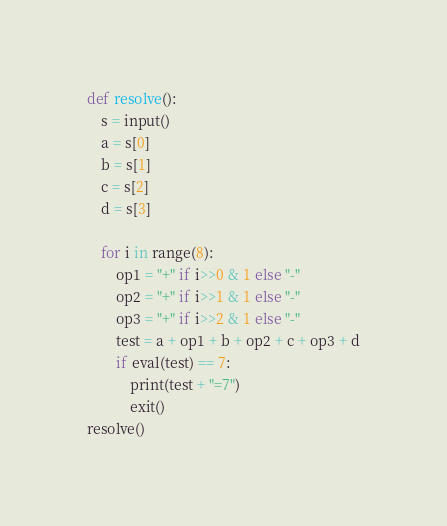<code> <loc_0><loc_0><loc_500><loc_500><_Python_>def resolve():
    s = input()
    a = s[0]
    b = s[1]
    c = s[2]
    d = s[3]

    for i in range(8):
        op1 = "+" if i>>0 & 1 else "-"
        op2 = "+" if i>>1 & 1 else "-"
        op3 = "+" if i>>2 & 1 else "-"
        test = a + op1 + b + op2 + c + op3 + d
        if eval(test) == 7:
            print(test + "=7")
            exit()
resolve()</code> 